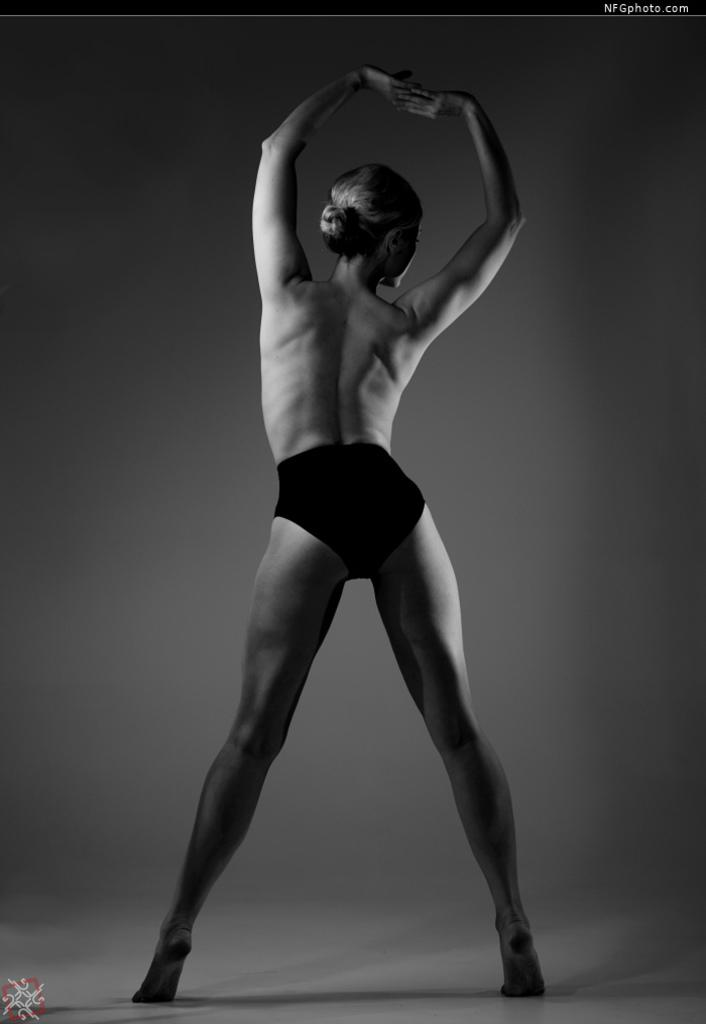What is the color scheme of the image? The image is black and white. Who is present in the image? There is a girl in the image. What is the girl doing in the image? The girl is standing on the floor. What is the girl wearing in the image? The girl is not wearing clothes in the image. What time of day is it in the image, given the presence of the morning sun? There is no mention of a morning sun or any time of day in the image, as it is a black and white image. 